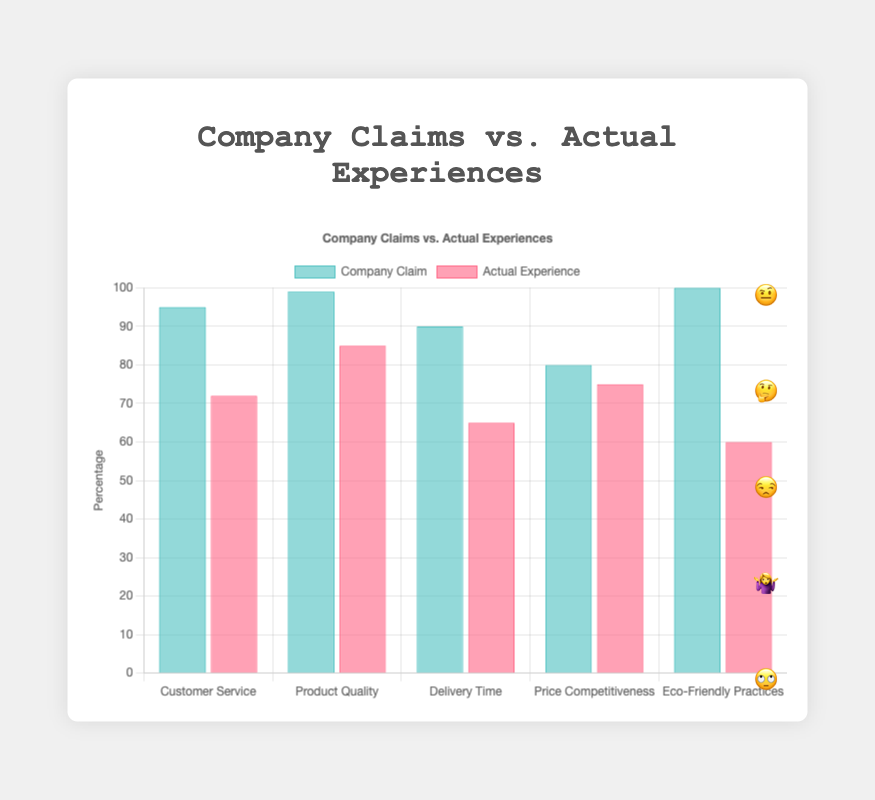what is the title of the chart? The title of the chart is displayed at the top center and reads "Company Claims vs. Actual Experiences"
Answer: Company Claims vs. Actual Experiences How many categories are compared in the chart? The chart compares 5 categories, which are listed on the x-axis: Customer Service, Product Quality, Delivery Time, Price Competitiveness, and Eco-Friendly Practices.
Answer: 5 Which category shows the biggest discrepancy between the company's claim and actual customer experience? The category with the biggest discrepancy is identified by looking for the largest visual gap between the company claim and the actual experience bars. Eco-Friendly Practices shows the largest gap, with the company claim at 100% and actual experience at 60%.
Answer: Eco-Friendly Practices In which category is the company's claim closest to the actual customer experience? The closest match can be found by identifying the smallest gap between the company claim and actual experience bars. This is Price Competitiveness, with a company claim of 80% and an actual experience of 75%.
Answer: Price Competitiveness What emoji represents the truthfulness for Eco-Friendly Practices? The emoji representing truthfulness for Eco-Friendly Practices is displayed next to the respective bars in the chart and is 🙄.
Answer: 🙄 What is the average percentage of actual customer experience across all categories? To find the average, the actual experience percentages (72 + 85 + 65 + 75 + 60) are summed up, totaling 357, and divided by the number of categories (5), resulting in an average of 71.4%.
Answer: 71.4% Which category shows the lowest actual customer experience percentage and what is the emoji associated with it? The lowest actual experience percentage is found in Eco-Friendly Practices at 60%, and the associated emoji is 🙄.
Answer: Eco-Friendly Practices, 🙄 How much higher is the company's claim percentage for Delivery Time compared to the actual customer experience? Subtract the actual experience percentage from the company claim percentage for Delivery Time: (90% - 65%) = 25%.
Answer: 25% What is the color used for the actual customer experience bars? The actual experience bars are colored in a shade of red as depicted by the specified background color for this dataset in the figure.
Answer: Red Which category's truthfulness emoji shows the least skepticism (neutral reaction)? The emoji indicating the least skepticism, which is a neutral reaction, is 🤷‍♀️ for Price Competitiveness.
Answer: Price Competitiveness, 🤷‍♀️ 